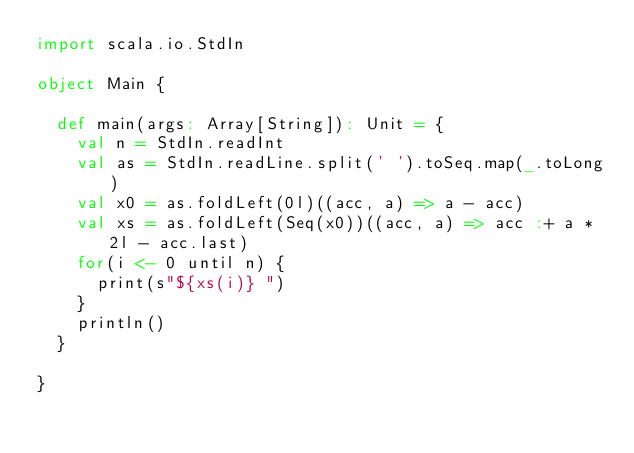Convert code to text. <code><loc_0><loc_0><loc_500><loc_500><_Scala_>import scala.io.StdIn

object Main {

  def main(args: Array[String]): Unit = {
    val n = StdIn.readInt
    val as = StdIn.readLine.split(' ').toSeq.map(_.toLong)
    val x0 = as.foldLeft(0l)((acc, a) => a - acc)
    val xs = as.foldLeft(Seq(x0))((acc, a) => acc :+ a * 2l - acc.last)
    for(i <- 0 until n) {
      print(s"${xs(i)} ")
    }
    println()
  }

}
</code> 